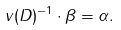Convert formula to latex. <formula><loc_0><loc_0><loc_500><loc_500>v ( D ) ^ { - 1 } \cdot \beta = \alpha .</formula> 